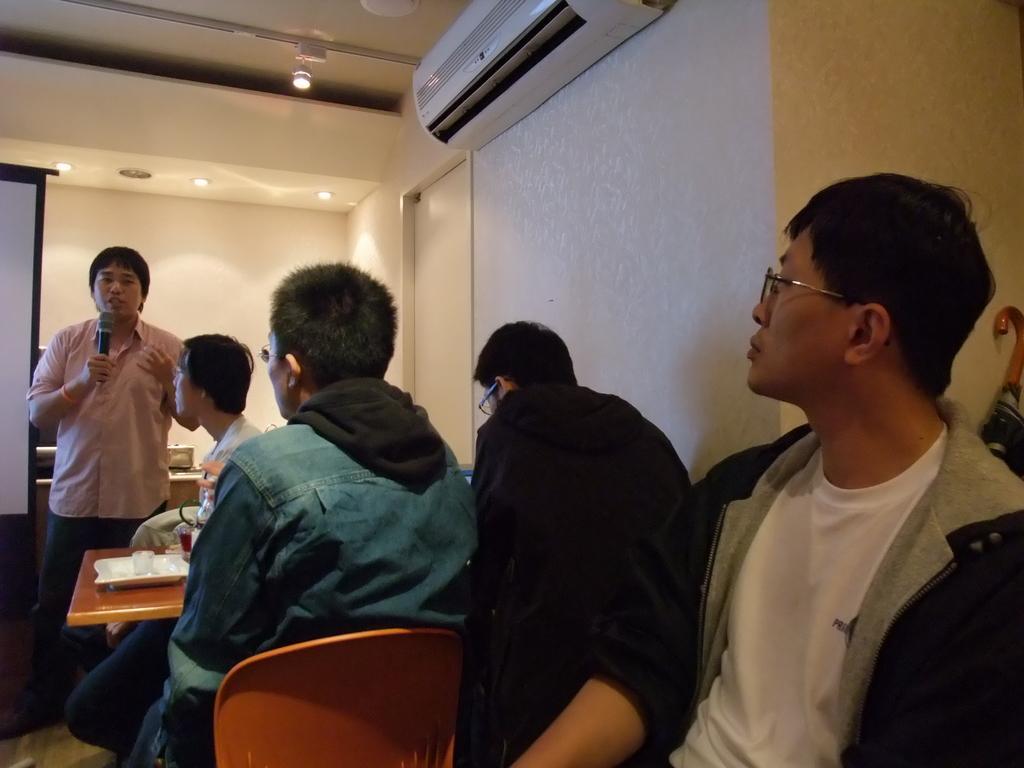In one or two sentences, can you explain what this image depicts? This is a picture taken in a room, there are four people sitting on chairs in front of these people there is a wooden table on the table there are tray, cup and bottle. A man in pink shirt was standing on the floor and the man is holding a microphone and explaining something. Behind the people there is a projector screen, wall on the wall there is AC and there are ceiling lights on the top. 